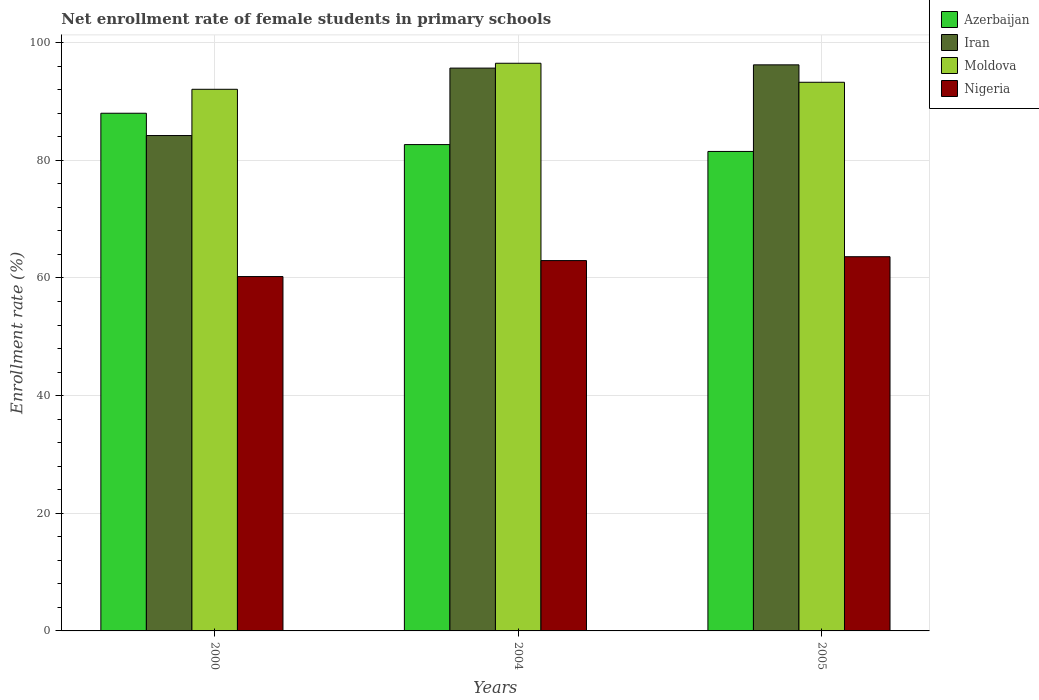What is the label of the 3rd group of bars from the left?
Your response must be concise. 2005. What is the net enrollment rate of female students in primary schools in Iran in 2000?
Keep it short and to the point. 84.22. Across all years, what is the maximum net enrollment rate of female students in primary schools in Iran?
Offer a terse response. 96.24. Across all years, what is the minimum net enrollment rate of female students in primary schools in Nigeria?
Give a very brief answer. 60.25. What is the total net enrollment rate of female students in primary schools in Azerbaijan in the graph?
Give a very brief answer. 252.21. What is the difference between the net enrollment rate of female students in primary schools in Nigeria in 2000 and that in 2005?
Provide a succinct answer. -3.37. What is the difference between the net enrollment rate of female students in primary schools in Iran in 2000 and the net enrollment rate of female students in primary schools in Azerbaijan in 2004?
Your answer should be compact. 1.54. What is the average net enrollment rate of female students in primary schools in Iran per year?
Offer a terse response. 92.05. In the year 2005, what is the difference between the net enrollment rate of female students in primary schools in Iran and net enrollment rate of female students in primary schools in Azerbaijan?
Give a very brief answer. 14.72. In how many years, is the net enrollment rate of female students in primary schools in Azerbaijan greater than 92 %?
Make the answer very short. 0. What is the ratio of the net enrollment rate of female students in primary schools in Azerbaijan in 2004 to that in 2005?
Your answer should be very brief. 1.01. Is the net enrollment rate of female students in primary schools in Moldova in 2000 less than that in 2005?
Offer a very short reply. Yes. What is the difference between the highest and the second highest net enrollment rate of female students in primary schools in Azerbaijan?
Make the answer very short. 5.33. What is the difference between the highest and the lowest net enrollment rate of female students in primary schools in Moldova?
Give a very brief answer. 4.42. Is it the case that in every year, the sum of the net enrollment rate of female students in primary schools in Iran and net enrollment rate of female students in primary schools in Nigeria is greater than the sum of net enrollment rate of female students in primary schools in Moldova and net enrollment rate of female students in primary schools in Azerbaijan?
Offer a terse response. No. What does the 4th bar from the left in 2005 represents?
Offer a very short reply. Nigeria. What does the 4th bar from the right in 2004 represents?
Make the answer very short. Azerbaijan. Is it the case that in every year, the sum of the net enrollment rate of female students in primary schools in Moldova and net enrollment rate of female students in primary schools in Iran is greater than the net enrollment rate of female students in primary schools in Azerbaijan?
Offer a terse response. Yes. Are all the bars in the graph horizontal?
Provide a succinct answer. No. What is the difference between two consecutive major ticks on the Y-axis?
Keep it short and to the point. 20. Does the graph contain any zero values?
Offer a terse response. No. Where does the legend appear in the graph?
Give a very brief answer. Top right. How are the legend labels stacked?
Your answer should be very brief. Vertical. What is the title of the graph?
Provide a succinct answer. Net enrollment rate of female students in primary schools. What is the label or title of the X-axis?
Your answer should be very brief. Years. What is the label or title of the Y-axis?
Give a very brief answer. Enrollment rate (%). What is the Enrollment rate (%) in Azerbaijan in 2000?
Provide a short and direct response. 88.01. What is the Enrollment rate (%) of Iran in 2000?
Your answer should be very brief. 84.22. What is the Enrollment rate (%) of Moldova in 2000?
Your response must be concise. 92.08. What is the Enrollment rate (%) of Nigeria in 2000?
Your response must be concise. 60.25. What is the Enrollment rate (%) in Azerbaijan in 2004?
Give a very brief answer. 82.68. What is the Enrollment rate (%) of Iran in 2004?
Offer a terse response. 95.68. What is the Enrollment rate (%) in Moldova in 2004?
Give a very brief answer. 96.51. What is the Enrollment rate (%) in Nigeria in 2004?
Ensure brevity in your answer.  62.96. What is the Enrollment rate (%) in Azerbaijan in 2005?
Ensure brevity in your answer.  81.52. What is the Enrollment rate (%) of Iran in 2005?
Provide a succinct answer. 96.24. What is the Enrollment rate (%) of Moldova in 2005?
Your response must be concise. 93.27. What is the Enrollment rate (%) in Nigeria in 2005?
Ensure brevity in your answer.  63.62. Across all years, what is the maximum Enrollment rate (%) of Azerbaijan?
Provide a short and direct response. 88.01. Across all years, what is the maximum Enrollment rate (%) of Iran?
Offer a terse response. 96.24. Across all years, what is the maximum Enrollment rate (%) in Moldova?
Offer a very short reply. 96.51. Across all years, what is the maximum Enrollment rate (%) of Nigeria?
Your response must be concise. 63.62. Across all years, what is the minimum Enrollment rate (%) in Azerbaijan?
Make the answer very short. 81.52. Across all years, what is the minimum Enrollment rate (%) of Iran?
Make the answer very short. 84.22. Across all years, what is the minimum Enrollment rate (%) of Moldova?
Offer a terse response. 92.08. Across all years, what is the minimum Enrollment rate (%) in Nigeria?
Make the answer very short. 60.25. What is the total Enrollment rate (%) of Azerbaijan in the graph?
Provide a succinct answer. 252.21. What is the total Enrollment rate (%) of Iran in the graph?
Make the answer very short. 276.14. What is the total Enrollment rate (%) in Moldova in the graph?
Provide a short and direct response. 281.86. What is the total Enrollment rate (%) in Nigeria in the graph?
Give a very brief answer. 186.83. What is the difference between the Enrollment rate (%) in Azerbaijan in 2000 and that in 2004?
Give a very brief answer. 5.33. What is the difference between the Enrollment rate (%) of Iran in 2000 and that in 2004?
Give a very brief answer. -11.46. What is the difference between the Enrollment rate (%) in Moldova in 2000 and that in 2004?
Make the answer very short. -4.42. What is the difference between the Enrollment rate (%) of Nigeria in 2000 and that in 2004?
Give a very brief answer. -2.71. What is the difference between the Enrollment rate (%) of Azerbaijan in 2000 and that in 2005?
Make the answer very short. 6.49. What is the difference between the Enrollment rate (%) of Iran in 2000 and that in 2005?
Your response must be concise. -12.02. What is the difference between the Enrollment rate (%) in Moldova in 2000 and that in 2005?
Provide a short and direct response. -1.19. What is the difference between the Enrollment rate (%) of Nigeria in 2000 and that in 2005?
Provide a short and direct response. -3.37. What is the difference between the Enrollment rate (%) in Azerbaijan in 2004 and that in 2005?
Offer a very short reply. 1.17. What is the difference between the Enrollment rate (%) of Iran in 2004 and that in 2005?
Offer a very short reply. -0.55. What is the difference between the Enrollment rate (%) in Moldova in 2004 and that in 2005?
Provide a short and direct response. 3.23. What is the difference between the Enrollment rate (%) of Nigeria in 2004 and that in 2005?
Provide a short and direct response. -0.66. What is the difference between the Enrollment rate (%) in Azerbaijan in 2000 and the Enrollment rate (%) in Iran in 2004?
Give a very brief answer. -7.67. What is the difference between the Enrollment rate (%) in Azerbaijan in 2000 and the Enrollment rate (%) in Moldova in 2004?
Provide a succinct answer. -8.5. What is the difference between the Enrollment rate (%) of Azerbaijan in 2000 and the Enrollment rate (%) of Nigeria in 2004?
Your answer should be very brief. 25.05. What is the difference between the Enrollment rate (%) in Iran in 2000 and the Enrollment rate (%) in Moldova in 2004?
Ensure brevity in your answer.  -12.29. What is the difference between the Enrollment rate (%) in Iran in 2000 and the Enrollment rate (%) in Nigeria in 2004?
Make the answer very short. 21.26. What is the difference between the Enrollment rate (%) of Moldova in 2000 and the Enrollment rate (%) of Nigeria in 2004?
Your answer should be compact. 29.12. What is the difference between the Enrollment rate (%) in Azerbaijan in 2000 and the Enrollment rate (%) in Iran in 2005?
Give a very brief answer. -8.23. What is the difference between the Enrollment rate (%) in Azerbaijan in 2000 and the Enrollment rate (%) in Moldova in 2005?
Your answer should be very brief. -5.26. What is the difference between the Enrollment rate (%) in Azerbaijan in 2000 and the Enrollment rate (%) in Nigeria in 2005?
Provide a succinct answer. 24.39. What is the difference between the Enrollment rate (%) of Iran in 2000 and the Enrollment rate (%) of Moldova in 2005?
Offer a very short reply. -9.05. What is the difference between the Enrollment rate (%) in Iran in 2000 and the Enrollment rate (%) in Nigeria in 2005?
Give a very brief answer. 20.6. What is the difference between the Enrollment rate (%) of Moldova in 2000 and the Enrollment rate (%) of Nigeria in 2005?
Offer a terse response. 28.46. What is the difference between the Enrollment rate (%) in Azerbaijan in 2004 and the Enrollment rate (%) in Iran in 2005?
Make the answer very short. -13.56. What is the difference between the Enrollment rate (%) of Azerbaijan in 2004 and the Enrollment rate (%) of Moldova in 2005?
Your answer should be compact. -10.59. What is the difference between the Enrollment rate (%) in Azerbaijan in 2004 and the Enrollment rate (%) in Nigeria in 2005?
Your answer should be compact. 19.06. What is the difference between the Enrollment rate (%) in Iran in 2004 and the Enrollment rate (%) in Moldova in 2005?
Offer a terse response. 2.41. What is the difference between the Enrollment rate (%) in Iran in 2004 and the Enrollment rate (%) in Nigeria in 2005?
Provide a short and direct response. 32.06. What is the difference between the Enrollment rate (%) of Moldova in 2004 and the Enrollment rate (%) of Nigeria in 2005?
Offer a terse response. 32.89. What is the average Enrollment rate (%) of Azerbaijan per year?
Offer a terse response. 84.07. What is the average Enrollment rate (%) of Iran per year?
Provide a succinct answer. 92.05. What is the average Enrollment rate (%) of Moldova per year?
Offer a terse response. 93.95. What is the average Enrollment rate (%) of Nigeria per year?
Offer a very short reply. 62.28. In the year 2000, what is the difference between the Enrollment rate (%) in Azerbaijan and Enrollment rate (%) in Iran?
Make the answer very short. 3.79. In the year 2000, what is the difference between the Enrollment rate (%) of Azerbaijan and Enrollment rate (%) of Moldova?
Offer a terse response. -4.07. In the year 2000, what is the difference between the Enrollment rate (%) of Azerbaijan and Enrollment rate (%) of Nigeria?
Provide a succinct answer. 27.76. In the year 2000, what is the difference between the Enrollment rate (%) in Iran and Enrollment rate (%) in Moldova?
Offer a terse response. -7.86. In the year 2000, what is the difference between the Enrollment rate (%) of Iran and Enrollment rate (%) of Nigeria?
Offer a terse response. 23.97. In the year 2000, what is the difference between the Enrollment rate (%) of Moldova and Enrollment rate (%) of Nigeria?
Keep it short and to the point. 31.84. In the year 2004, what is the difference between the Enrollment rate (%) of Azerbaijan and Enrollment rate (%) of Iran?
Ensure brevity in your answer.  -13. In the year 2004, what is the difference between the Enrollment rate (%) of Azerbaijan and Enrollment rate (%) of Moldova?
Your answer should be compact. -13.83. In the year 2004, what is the difference between the Enrollment rate (%) of Azerbaijan and Enrollment rate (%) of Nigeria?
Keep it short and to the point. 19.72. In the year 2004, what is the difference between the Enrollment rate (%) of Iran and Enrollment rate (%) of Moldova?
Make the answer very short. -0.82. In the year 2004, what is the difference between the Enrollment rate (%) in Iran and Enrollment rate (%) in Nigeria?
Your answer should be compact. 32.72. In the year 2004, what is the difference between the Enrollment rate (%) of Moldova and Enrollment rate (%) of Nigeria?
Your answer should be compact. 33.55. In the year 2005, what is the difference between the Enrollment rate (%) in Azerbaijan and Enrollment rate (%) in Iran?
Make the answer very short. -14.72. In the year 2005, what is the difference between the Enrollment rate (%) of Azerbaijan and Enrollment rate (%) of Moldova?
Ensure brevity in your answer.  -11.76. In the year 2005, what is the difference between the Enrollment rate (%) in Azerbaijan and Enrollment rate (%) in Nigeria?
Give a very brief answer. 17.9. In the year 2005, what is the difference between the Enrollment rate (%) of Iran and Enrollment rate (%) of Moldova?
Make the answer very short. 2.96. In the year 2005, what is the difference between the Enrollment rate (%) of Iran and Enrollment rate (%) of Nigeria?
Ensure brevity in your answer.  32.62. In the year 2005, what is the difference between the Enrollment rate (%) of Moldova and Enrollment rate (%) of Nigeria?
Your answer should be compact. 29.65. What is the ratio of the Enrollment rate (%) of Azerbaijan in 2000 to that in 2004?
Your answer should be very brief. 1.06. What is the ratio of the Enrollment rate (%) in Iran in 2000 to that in 2004?
Offer a very short reply. 0.88. What is the ratio of the Enrollment rate (%) of Moldova in 2000 to that in 2004?
Provide a succinct answer. 0.95. What is the ratio of the Enrollment rate (%) of Nigeria in 2000 to that in 2004?
Make the answer very short. 0.96. What is the ratio of the Enrollment rate (%) of Azerbaijan in 2000 to that in 2005?
Provide a short and direct response. 1.08. What is the ratio of the Enrollment rate (%) of Iran in 2000 to that in 2005?
Make the answer very short. 0.88. What is the ratio of the Enrollment rate (%) in Moldova in 2000 to that in 2005?
Make the answer very short. 0.99. What is the ratio of the Enrollment rate (%) in Nigeria in 2000 to that in 2005?
Provide a succinct answer. 0.95. What is the ratio of the Enrollment rate (%) in Azerbaijan in 2004 to that in 2005?
Provide a succinct answer. 1.01. What is the ratio of the Enrollment rate (%) in Iran in 2004 to that in 2005?
Provide a short and direct response. 0.99. What is the ratio of the Enrollment rate (%) in Moldova in 2004 to that in 2005?
Your answer should be very brief. 1.03. What is the ratio of the Enrollment rate (%) in Nigeria in 2004 to that in 2005?
Give a very brief answer. 0.99. What is the difference between the highest and the second highest Enrollment rate (%) of Azerbaijan?
Offer a terse response. 5.33. What is the difference between the highest and the second highest Enrollment rate (%) of Iran?
Your response must be concise. 0.55. What is the difference between the highest and the second highest Enrollment rate (%) of Moldova?
Keep it short and to the point. 3.23. What is the difference between the highest and the second highest Enrollment rate (%) of Nigeria?
Provide a succinct answer. 0.66. What is the difference between the highest and the lowest Enrollment rate (%) of Azerbaijan?
Offer a very short reply. 6.49. What is the difference between the highest and the lowest Enrollment rate (%) of Iran?
Your answer should be compact. 12.02. What is the difference between the highest and the lowest Enrollment rate (%) in Moldova?
Make the answer very short. 4.42. What is the difference between the highest and the lowest Enrollment rate (%) of Nigeria?
Provide a short and direct response. 3.37. 